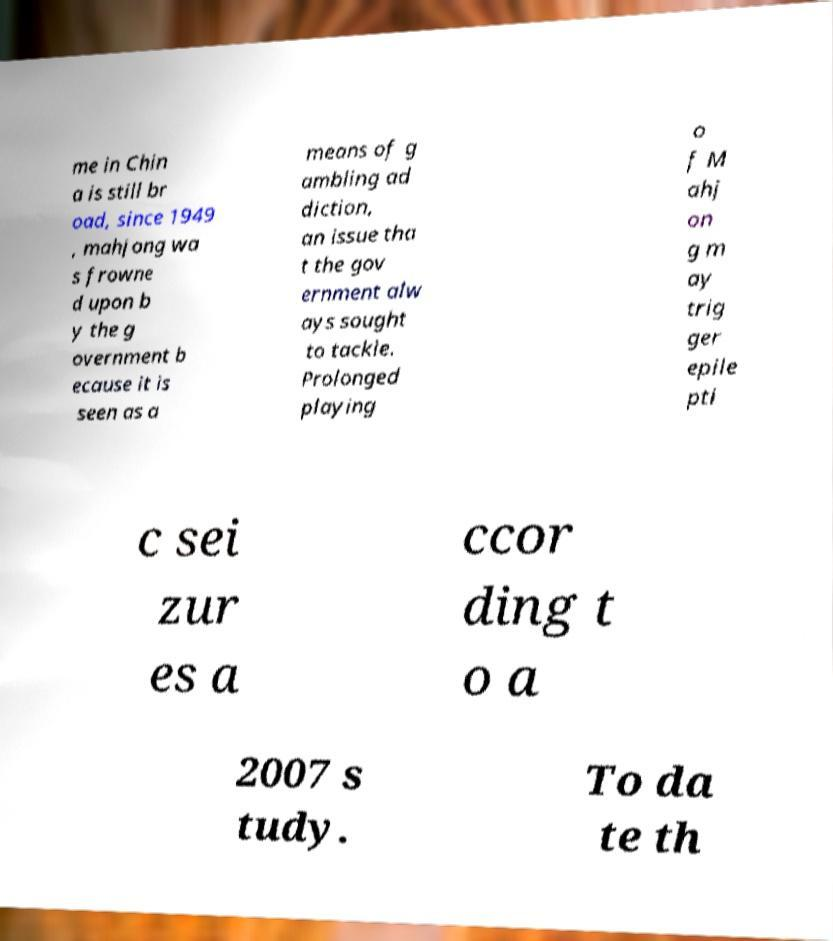I need the written content from this picture converted into text. Can you do that? me in Chin a is still br oad, since 1949 , mahjong wa s frowne d upon b y the g overnment b ecause it is seen as a means of g ambling ad diction, an issue tha t the gov ernment alw ays sought to tackle. Prolonged playing o f M ahj on g m ay trig ger epile pti c sei zur es a ccor ding t o a 2007 s tudy. To da te th 